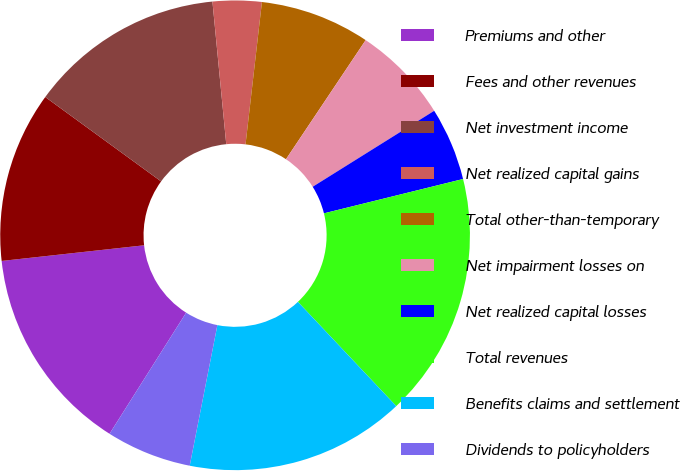<chart> <loc_0><loc_0><loc_500><loc_500><pie_chart><fcel>Premiums and other<fcel>Fees and other revenues<fcel>Net investment income<fcel>Net realized capital gains<fcel>Total other-than-temporary<fcel>Net impairment losses on<fcel>Net realized capital losses<fcel>Total revenues<fcel>Benefits claims and settlement<fcel>Dividends to policyholders<nl><fcel>14.28%<fcel>11.76%<fcel>13.44%<fcel>3.36%<fcel>7.56%<fcel>6.72%<fcel>5.04%<fcel>16.81%<fcel>15.13%<fcel>5.88%<nl></chart> 